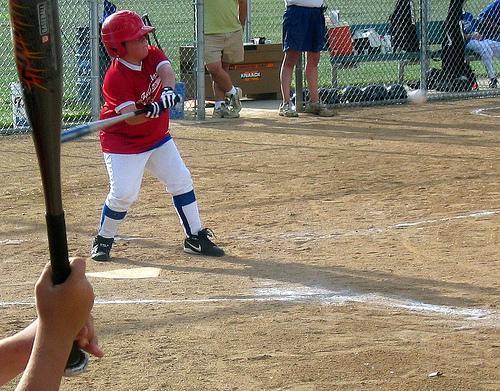How many people can you see?
Give a very brief answer. 4. How many motorcycles are between the sidewalk and the yellow line in the road?
Give a very brief answer. 0. 